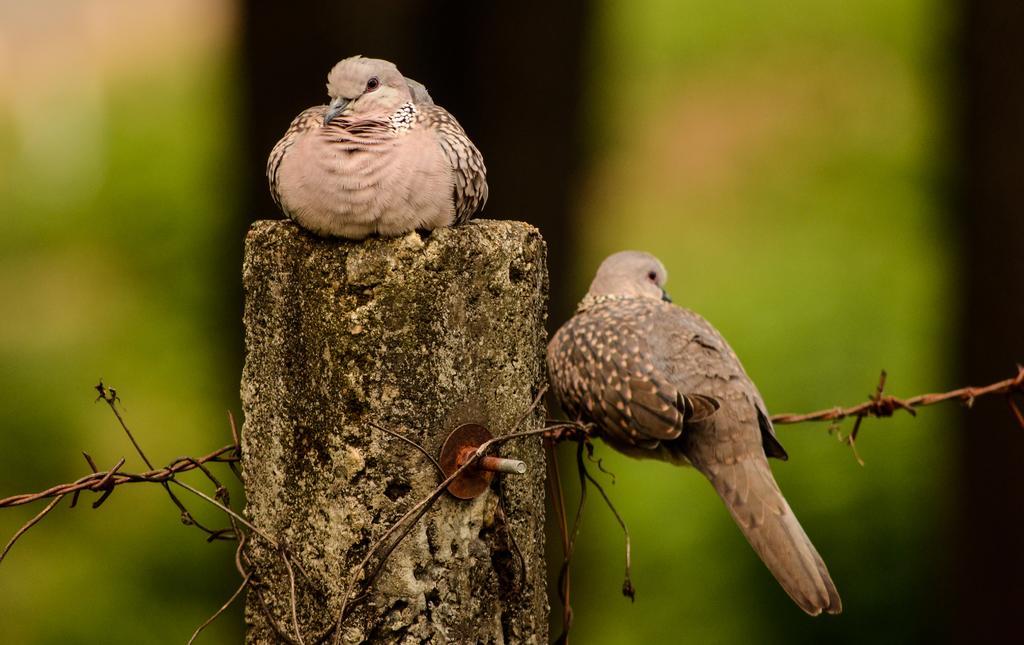In one or two sentences, can you explain what this image depicts? In the picture I can see birds, one bird is sitting on the pillar and another bird is sitting on the fence. 